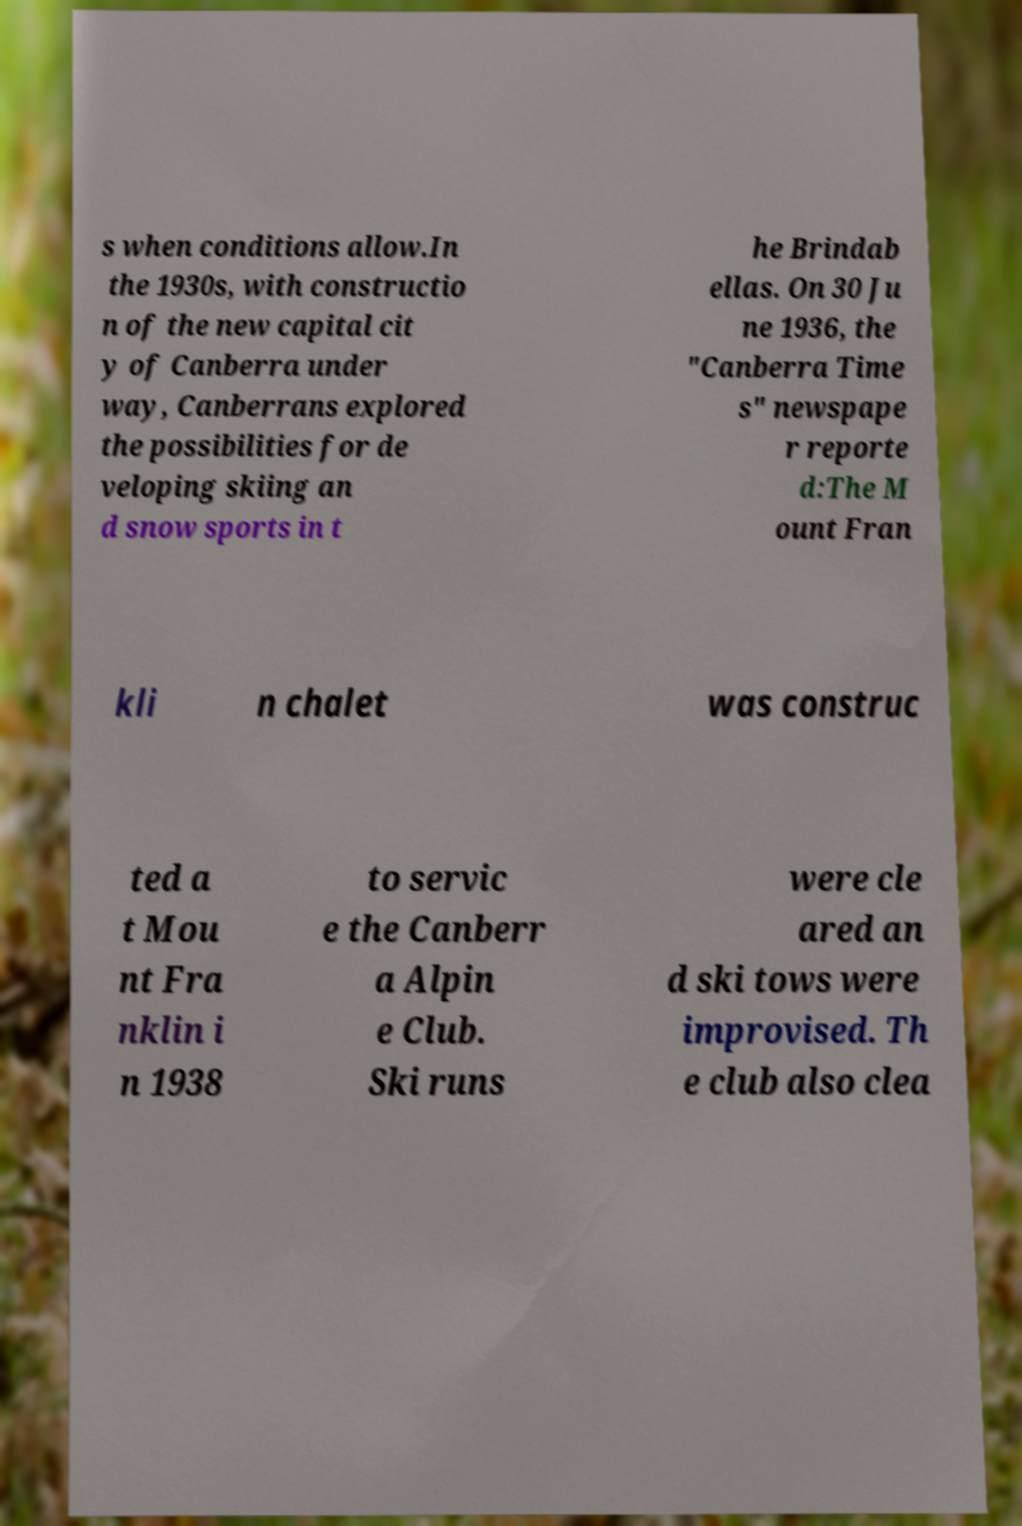Could you extract and type out the text from this image? s when conditions allow.In the 1930s, with constructio n of the new capital cit y of Canberra under way, Canberrans explored the possibilities for de veloping skiing an d snow sports in t he Brindab ellas. On 30 Ju ne 1936, the "Canberra Time s" newspape r reporte d:The M ount Fran kli n chalet was construc ted a t Mou nt Fra nklin i n 1938 to servic e the Canberr a Alpin e Club. Ski runs were cle ared an d ski tows were improvised. Th e club also clea 